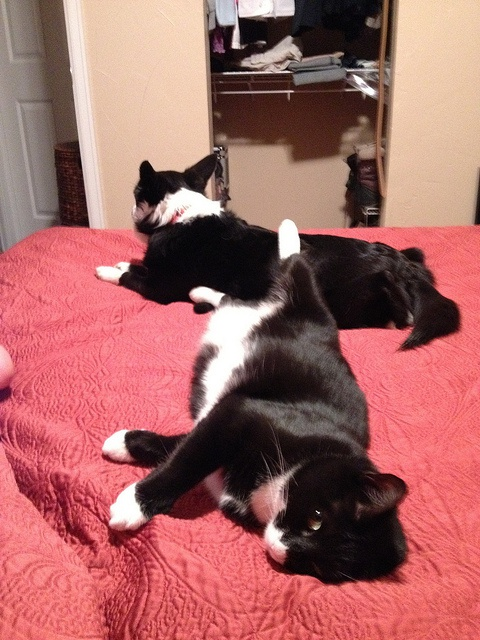Describe the objects in this image and their specific colors. I can see bed in darkgray, salmon, and brown tones, cat in darkgray, black, gray, white, and maroon tones, and cat in darkgray, black, white, maroon, and gray tones in this image. 